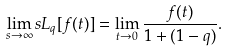Convert formula to latex. <formula><loc_0><loc_0><loc_500><loc_500>\lim _ { s \rightarrow \infty } s L _ { q } [ f ( t ) ] = \lim _ { t \rightarrow 0 } \frac { f ( t ) } { 1 + ( 1 - q ) } .</formula> 